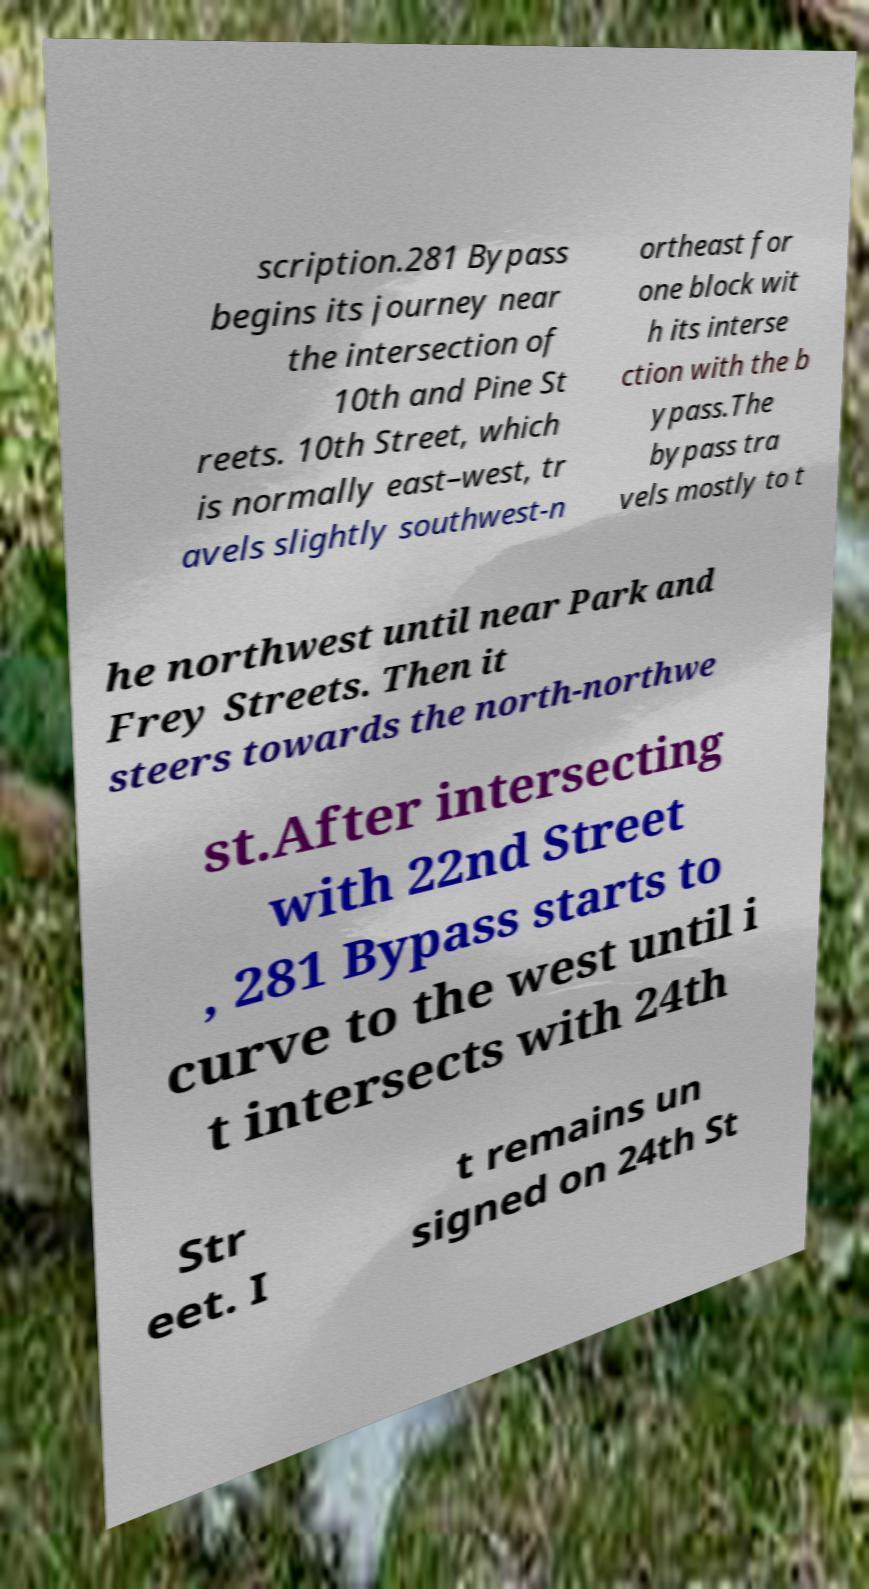I need the written content from this picture converted into text. Can you do that? scription.281 Bypass begins its journey near the intersection of 10th and Pine St reets. 10th Street, which is normally east–west, tr avels slightly southwest-n ortheast for one block wit h its interse ction with the b ypass.The bypass tra vels mostly to t he northwest until near Park and Frey Streets. Then it steers towards the north-northwe st.After intersecting with 22nd Street , 281 Bypass starts to curve to the west until i t intersects with 24th Str eet. I t remains un signed on 24th St 